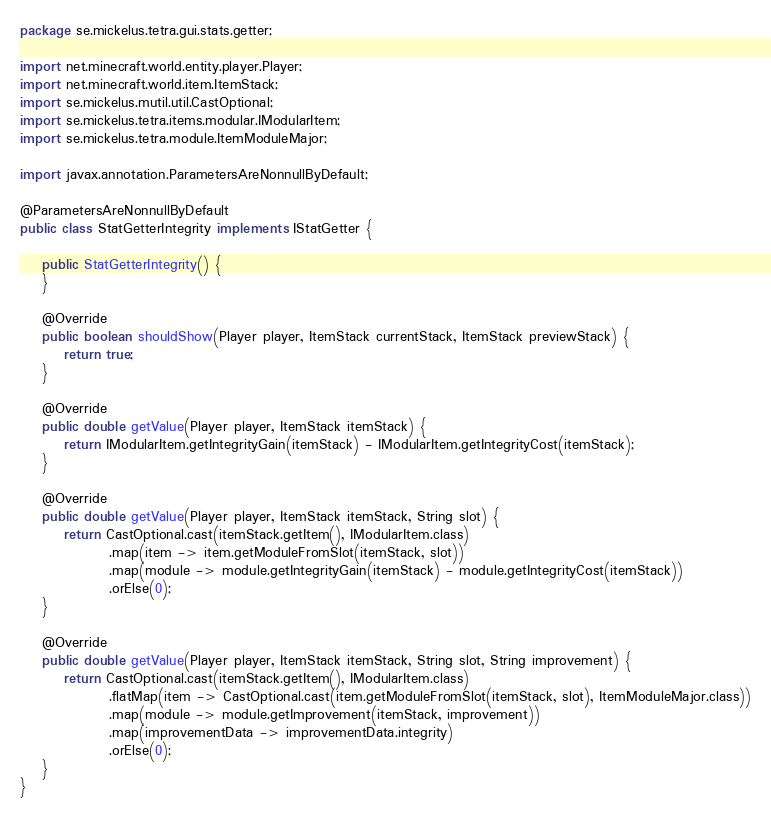<code> <loc_0><loc_0><loc_500><loc_500><_Java_>package se.mickelus.tetra.gui.stats.getter;

import net.minecraft.world.entity.player.Player;
import net.minecraft.world.item.ItemStack;
import se.mickelus.mutil.util.CastOptional;
import se.mickelus.tetra.items.modular.IModularItem;
import se.mickelus.tetra.module.ItemModuleMajor;

import javax.annotation.ParametersAreNonnullByDefault;

@ParametersAreNonnullByDefault
public class StatGetterIntegrity implements IStatGetter {

    public StatGetterIntegrity() {
    }

    @Override
    public boolean shouldShow(Player player, ItemStack currentStack, ItemStack previewStack) {
        return true;
    }

    @Override
    public double getValue(Player player, ItemStack itemStack) {
        return IModularItem.getIntegrityGain(itemStack) - IModularItem.getIntegrityCost(itemStack);
    }

    @Override
    public double getValue(Player player, ItemStack itemStack, String slot) {
        return CastOptional.cast(itemStack.getItem(), IModularItem.class)
                .map(item -> item.getModuleFromSlot(itemStack, slot))
                .map(module -> module.getIntegrityGain(itemStack) - module.getIntegrityCost(itemStack))
                .orElse(0);
    }

    @Override
    public double getValue(Player player, ItemStack itemStack, String slot, String improvement) {
        return CastOptional.cast(itemStack.getItem(), IModularItem.class)
                .flatMap(item -> CastOptional.cast(item.getModuleFromSlot(itemStack, slot), ItemModuleMajor.class))
                .map(module -> module.getImprovement(itemStack, improvement))
                .map(improvementData -> improvementData.integrity)
                .orElse(0);
    }
}
</code> 